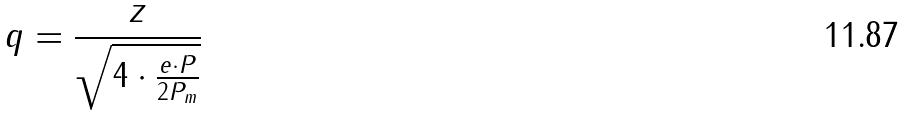<formula> <loc_0><loc_0><loc_500><loc_500>q = \frac { z } { \sqrt { 4 \cdot \frac { e \cdot P } { 2 P _ { m } } } }</formula> 